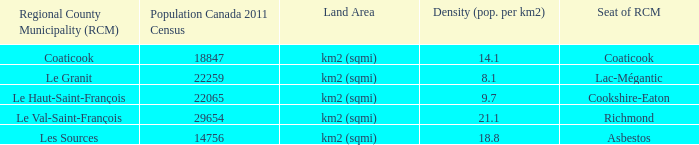What is the land area of the RCM having a density of 21.1? Km2 (sqmi). 